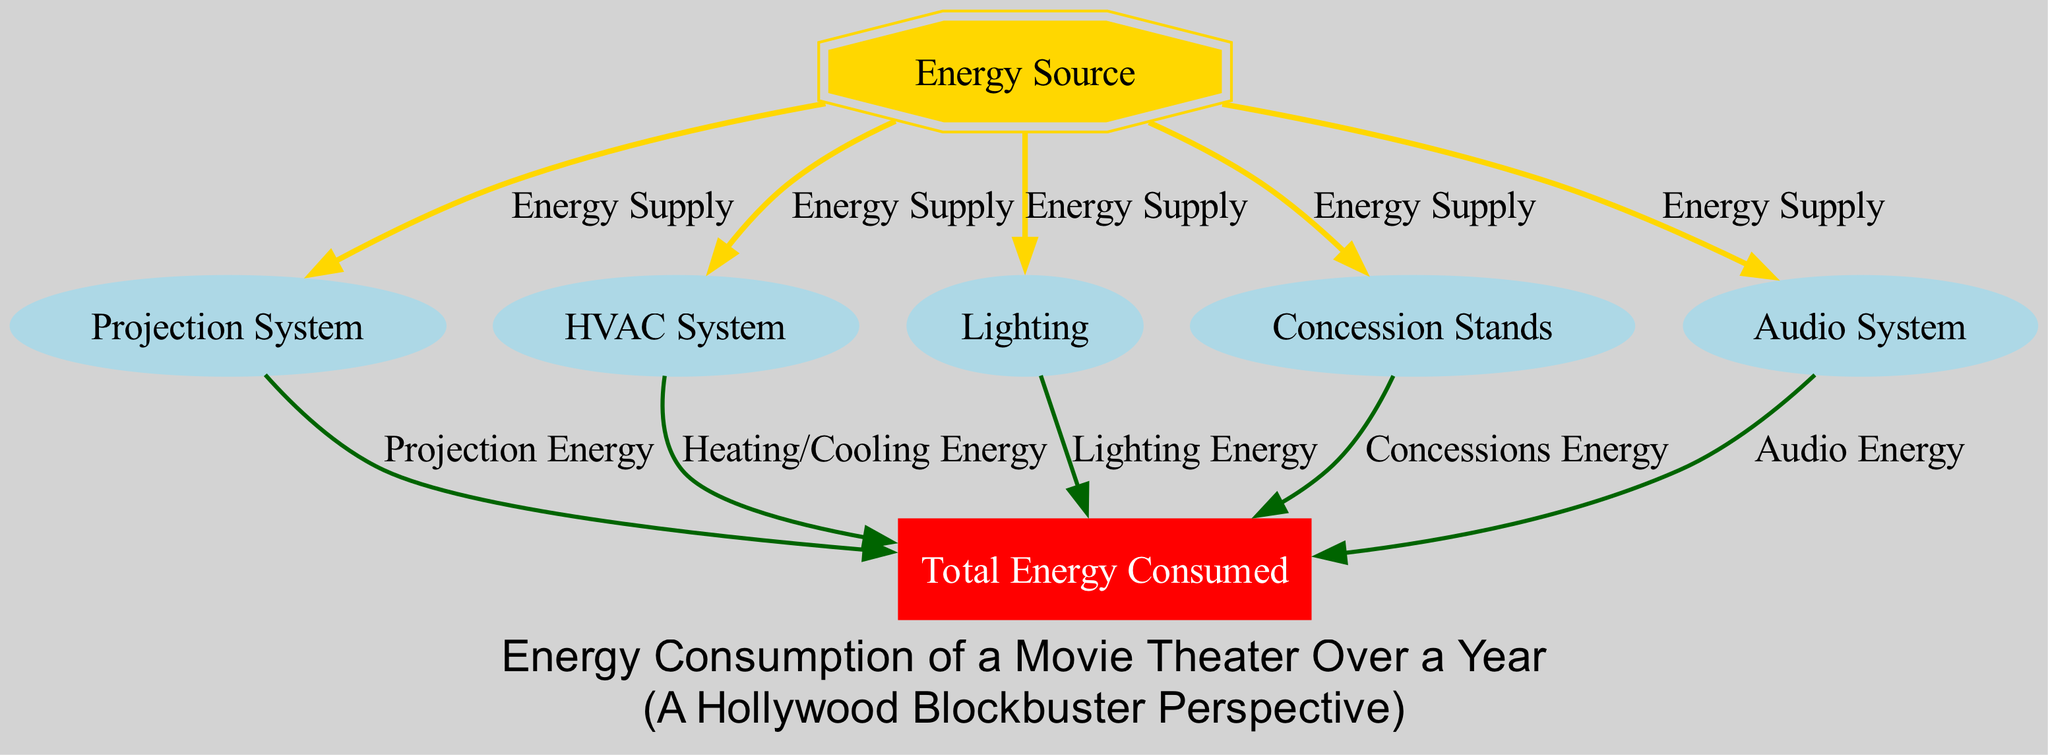What is the total energy consumed by the movie theater? The diagram shows a node labeled "Total Energy Consumed," which represents the cumulative energy used by the theater. This is the endpoint to which various energy sources contribute, but the figure does not provide an explicit numerical value.
Answer: Total Energy Consumed What type of node is the "Energy Source"? In the diagram, "Energy Source" is represented by a doubleoctagon shape, which signifies a unique node type compared to others.
Answer: doubleoctagon How many systems contribute to the total energy consumed? By counting the edges flowing into the "Total Energy Consumed" node, we see that there are five distinct sources of energy that contribute: Projection System, HVAC System, Lighting, Concession Stands, and Audio System.
Answer: Five What color represents the edges labeled “Energy Supply”? The diagram uses gold color for the edges indicating "Energy Supply," which visually distinguishes them from other edge types.
Answer: Gold Which system has the most direct connection to the energy source? All systems (Projection System, HVAC, Lighting, Concession Stands, and Audio System) have a direct connection to the "Energy Source," but there is no specific indicator in the diagram for which system uses the most energy. However, they all share the same connection path.
Answer: All systems What is the significance of the “Total Energy Consumed” node? The "Total Energy Consumed" node aggregates the energy inputs from all subsystems, serving as a summary indicator of the movie theater’s yearly energy usage. This node captures the overall consumption resulting from various systems' activities.
Answer: Aggregator of energy consumption Which component is responsible for audio energy? The "Audio System" node is dedicated to energy consumption related to audio functions within the movie theater, as directly indicated by the edges flowing from it to the total energy consumed node.
Answer: Audio System What color is used for the "Total Energy Consumed" node? The node labeled "Total Energy Consumed" is filled with red color, distinguishing it visually as a critical summary indicator in the diagram.
Answer: Red 